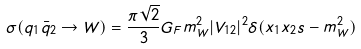<formula> <loc_0><loc_0><loc_500><loc_500>\sigma ( q _ { 1 } \bar { q } _ { 2 } \rightarrow W ) = \frac { \pi \sqrt { 2 } } { 3 } G _ { F } m ^ { 2 } _ { W } | V _ { 1 2 } | ^ { 2 } \delta ( x _ { 1 } x _ { 2 } s - m ^ { 2 } _ { W } )</formula> 